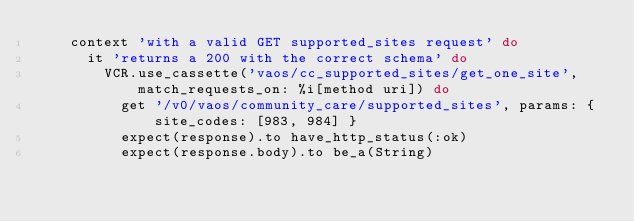Convert code to text. <code><loc_0><loc_0><loc_500><loc_500><_Ruby_>    context 'with a valid GET supported_sites request' do
      it 'returns a 200 with the correct schema' do
        VCR.use_cassette('vaos/cc_supported_sites/get_one_site', match_requests_on: %i[method uri]) do
          get '/v0/vaos/community_care/supported_sites', params: { site_codes: [983, 984] }
          expect(response).to have_http_status(:ok)
          expect(response.body).to be_a(String)</code> 